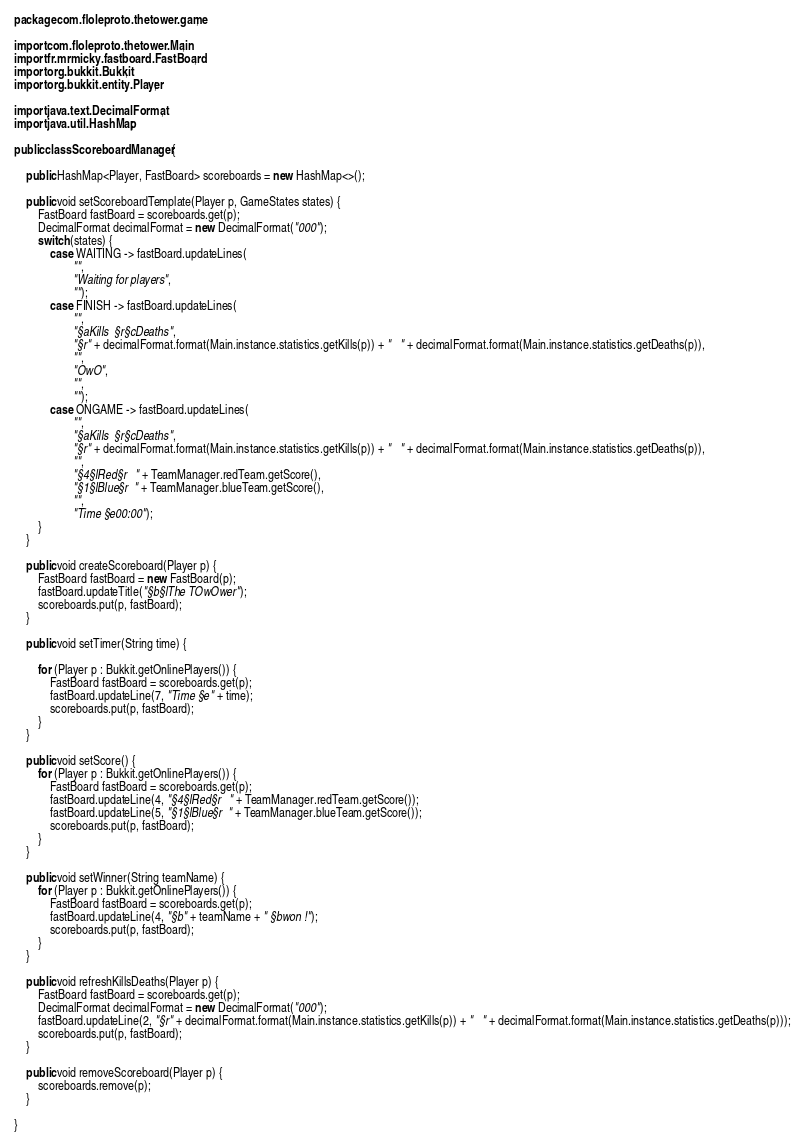<code> <loc_0><loc_0><loc_500><loc_500><_Java_>package com.floleproto.thetower.game;

import com.floleproto.thetower.Main;
import fr.mrmicky.fastboard.FastBoard;
import org.bukkit.Bukkit;
import org.bukkit.entity.Player;

import java.text.DecimalFormat;
import java.util.HashMap;

public class ScoreboardManager {

    public HashMap<Player, FastBoard> scoreboards = new HashMap<>();

    public void setScoreboardTemplate(Player p, GameStates states) {
        FastBoard fastBoard = scoreboards.get(p);
        DecimalFormat decimalFormat = new DecimalFormat("000");
        switch (states) {
            case WAITING -> fastBoard.updateLines(
                    "",
                    "Waiting for players",
                    "");
            case FINISH -> fastBoard.updateLines(
                    "",
                    "§aKills  §r§cDeaths",
                    "§r" + decimalFormat.format(Main.instance.statistics.getKills(p)) + "   " + decimalFormat.format(Main.instance.statistics.getDeaths(p)),
                    "",
                    "OwO",
                    "",
                    "");
            case ONGAME -> fastBoard.updateLines(
                    "",
                    "§aKills  §r§cDeaths",
                    "§r" + decimalFormat.format(Main.instance.statistics.getKills(p)) + "   " + decimalFormat.format(Main.instance.statistics.getDeaths(p)),
                    "",
                    "§4§lRed§r   " + TeamManager.redTeam.getScore(),
                    "§1§lBlue§r  " + TeamManager.blueTeam.getScore(),
                    "",
                    "Time §e00:00");
        }
    }

    public void createScoreboard(Player p) {
        FastBoard fastBoard = new FastBoard(p);
        fastBoard.updateTitle("§b§lThe TOwOwer");
        scoreboards.put(p, fastBoard);
    }

    public void setTimer(String time) {

        for (Player p : Bukkit.getOnlinePlayers()) {
            FastBoard fastBoard = scoreboards.get(p);
            fastBoard.updateLine(7, "Time §e" + time);
            scoreboards.put(p, fastBoard);
        }
    }

    public void setScore() {
        for (Player p : Bukkit.getOnlinePlayers()) {
            FastBoard fastBoard = scoreboards.get(p);
            fastBoard.updateLine(4, "§4§lRed§r   " + TeamManager.redTeam.getScore());
            fastBoard.updateLine(5, "§1§lBlue§r  " + TeamManager.blueTeam.getScore());
            scoreboards.put(p, fastBoard);
        }
    }

    public void setWinner(String teamName) {
        for (Player p : Bukkit.getOnlinePlayers()) {
            FastBoard fastBoard = scoreboards.get(p);
            fastBoard.updateLine(4, "§b" + teamName + " §bwon !");
            scoreboards.put(p, fastBoard);
        }
    }

    public void refreshKillsDeaths(Player p) {
        FastBoard fastBoard = scoreboards.get(p);
        DecimalFormat decimalFormat = new DecimalFormat("000");
        fastBoard.updateLine(2, "§r" + decimalFormat.format(Main.instance.statistics.getKills(p)) + "   " + decimalFormat.format(Main.instance.statistics.getDeaths(p)));
        scoreboards.put(p, fastBoard);
    }

    public void removeScoreboard(Player p) {
        scoreboards.remove(p);
    }

}
</code> 